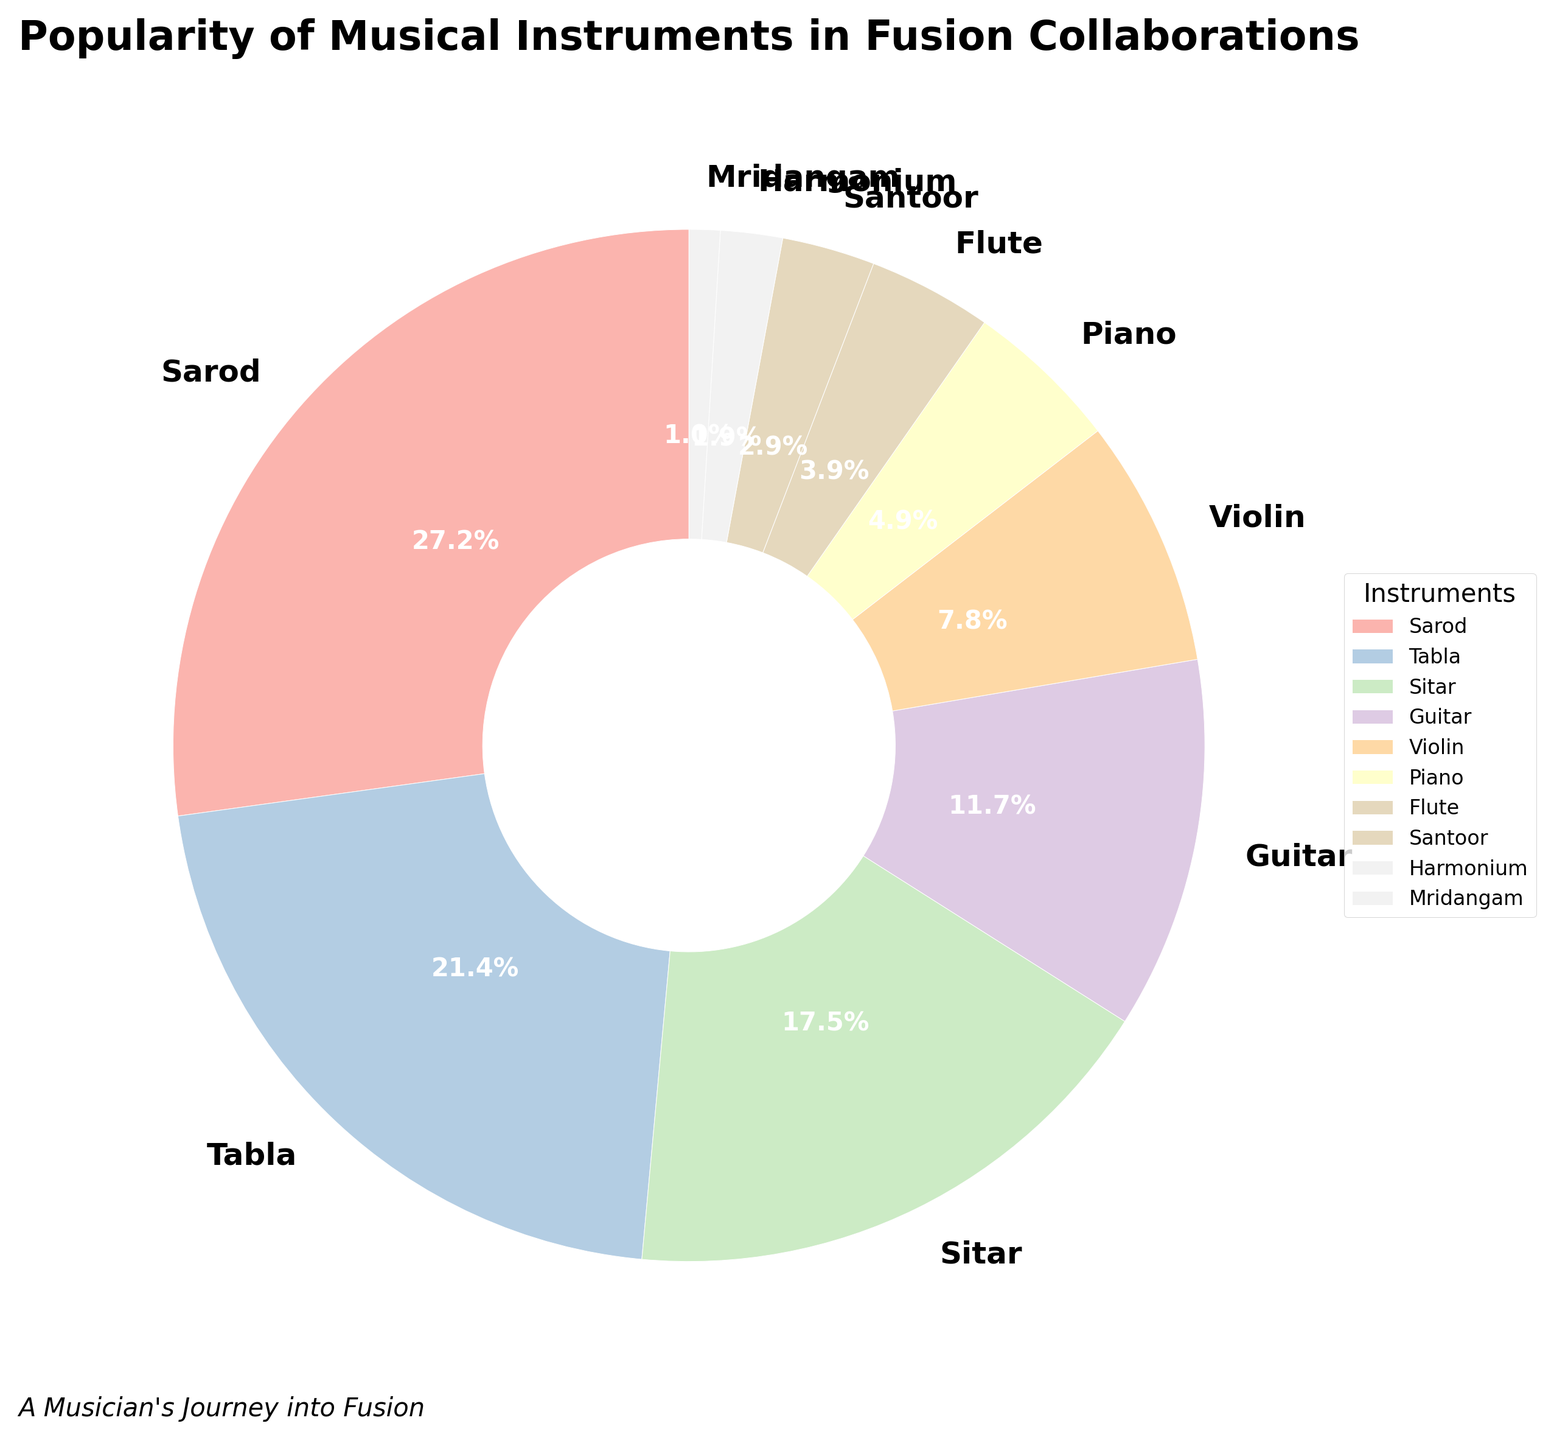Which instrument is the most popular in fusion collaborations? The pie chart indicates that Sarod has the largest section out of all the instruments listed, with 28%.
Answer: Sarod What is the combined popularity percentage of Tabla and Sitar? According to the pie chart, Tabla has 22% and Sitar has 18%. Adding these two percentages together, we get 22% + 18% = 40%.
Answer: 40% Which instruments have a lower popularity than Piano in fusion collaborations? In the pie chart, Piano has 5%. Instruments with a lower percentage are Flute (4%), Santoor (3%), Harmonium (2%), and Mridangam (1%).
Answer: Flute, Santoor, Harmonium, Mridangam Is the percentage of Guitar higher, lower, or equal to that of Violin? The pie chart shows that Guitar has a popularity of 12%, while Violin has 8%. Therefore, Guitar's percentage is higher than that of Violin.
Answer: Higher What percentage of the pie chart is accounted for by instruments other than Sarod and Tabla? According to the pie chart, Sarod is 28% and Tabla is 22%. Together they account for 28% + 22% = 50%. Therefore, instruments other than Sarod and Tabla account for 100% - 50% = 50%.
Answer: 50% How much more popular is the Sarod compared to the Mridangam? The pie chart shows that Sarod has 28% and Mridangam has 1%. The difference in their popularity is 28% - 1% = 27%.
Answer: 27% What is the average popularity percentage of the Sitar, Violin, and Piano? According to the pie chart, Sitar has 18%, Violin has 8%, and Piano has 5%. The total is 18% + 8% + 5% = 31%. The average is 31% / 3 = 10.33%.
Answer: 10.33% If you were to rank the popularity of the Guitar, Flute, and Santoor from highest to lowest, what would the order be? The pie chart shows Guitar at 12%, Flute at 4%, and Santoor at 3%. Therefore, the order from highest to lowest is Guitar, Flute, Santoor.
Answer: Guitar, Flute, Santoor Which instrument has a similar popularity percentage to the Guitar? The pie chart indicates that Guitar has 12%. Among other instruments, there is no exact percentage match for 12%, but Tabla at 22% and Sitar at 18% are the closest in terms of size.
Answer: None 